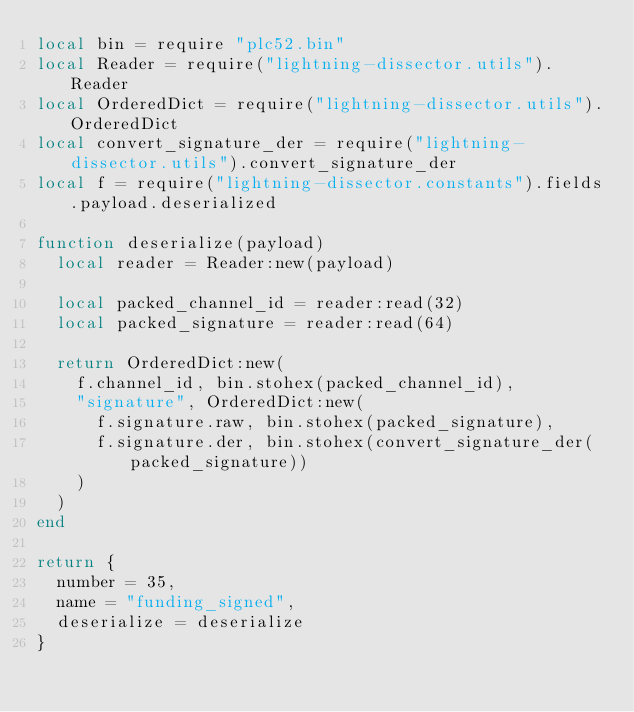Convert code to text. <code><loc_0><loc_0><loc_500><loc_500><_Lua_>local bin = require "plc52.bin"
local Reader = require("lightning-dissector.utils").Reader
local OrderedDict = require("lightning-dissector.utils").OrderedDict
local convert_signature_der = require("lightning-dissector.utils").convert_signature_der
local f = require("lightning-dissector.constants").fields.payload.deserialized

function deserialize(payload)
  local reader = Reader:new(payload)

  local packed_channel_id = reader:read(32)
  local packed_signature = reader:read(64)

  return OrderedDict:new(
    f.channel_id, bin.stohex(packed_channel_id),
    "signature", OrderedDict:new(
      f.signature.raw, bin.stohex(packed_signature),
      f.signature.der, bin.stohex(convert_signature_der(packed_signature))
    )
  )
end

return {
  number = 35,
  name = "funding_signed",
  deserialize = deserialize
}
</code> 